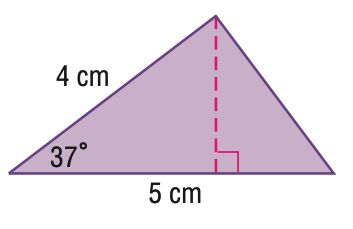Answer the mathemtical geometry problem and directly provide the correct option letter.
Question: Find the area of the triangle. Round to the nearest hundredth.
Choices: A: 6.02 B: 7.54 C: 7.99 D: 9.42 A 